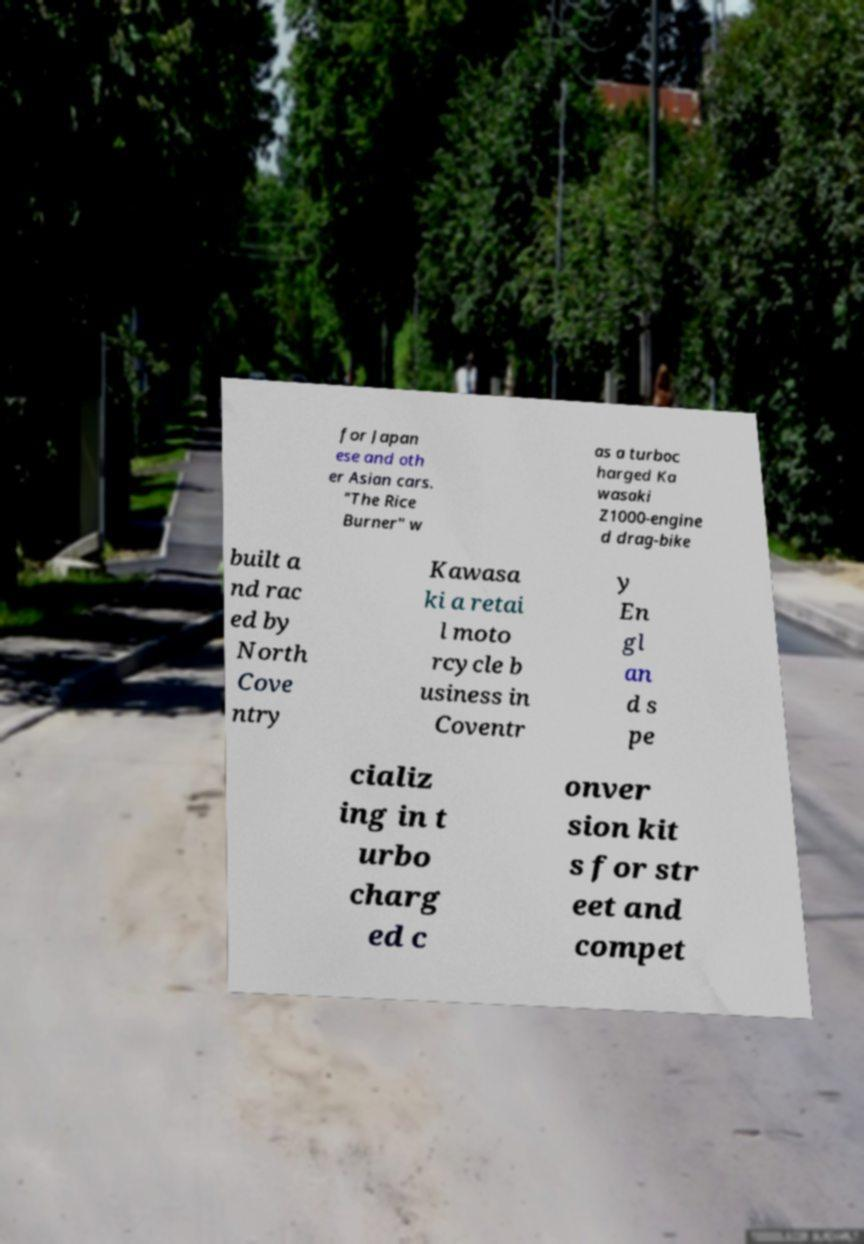Please identify and transcribe the text found in this image. for Japan ese and oth er Asian cars. "The Rice Burner" w as a turboc harged Ka wasaki Z1000-engine d drag-bike built a nd rac ed by North Cove ntry Kawasa ki a retai l moto rcycle b usiness in Coventr y En gl an d s pe cializ ing in t urbo charg ed c onver sion kit s for str eet and compet 